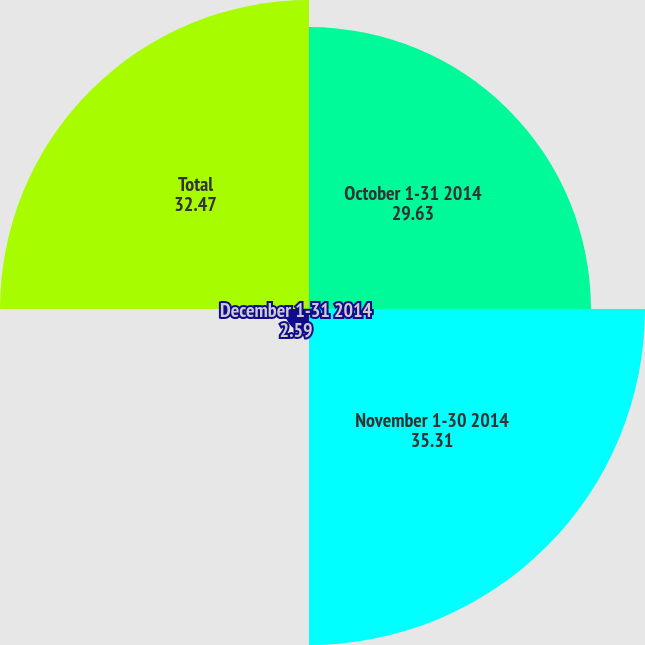<chart> <loc_0><loc_0><loc_500><loc_500><pie_chart><fcel>October 1-31 2014<fcel>November 1-30 2014<fcel>December 1-31 2014<fcel>Total<nl><fcel>29.63%<fcel>35.31%<fcel>2.59%<fcel>32.47%<nl></chart> 